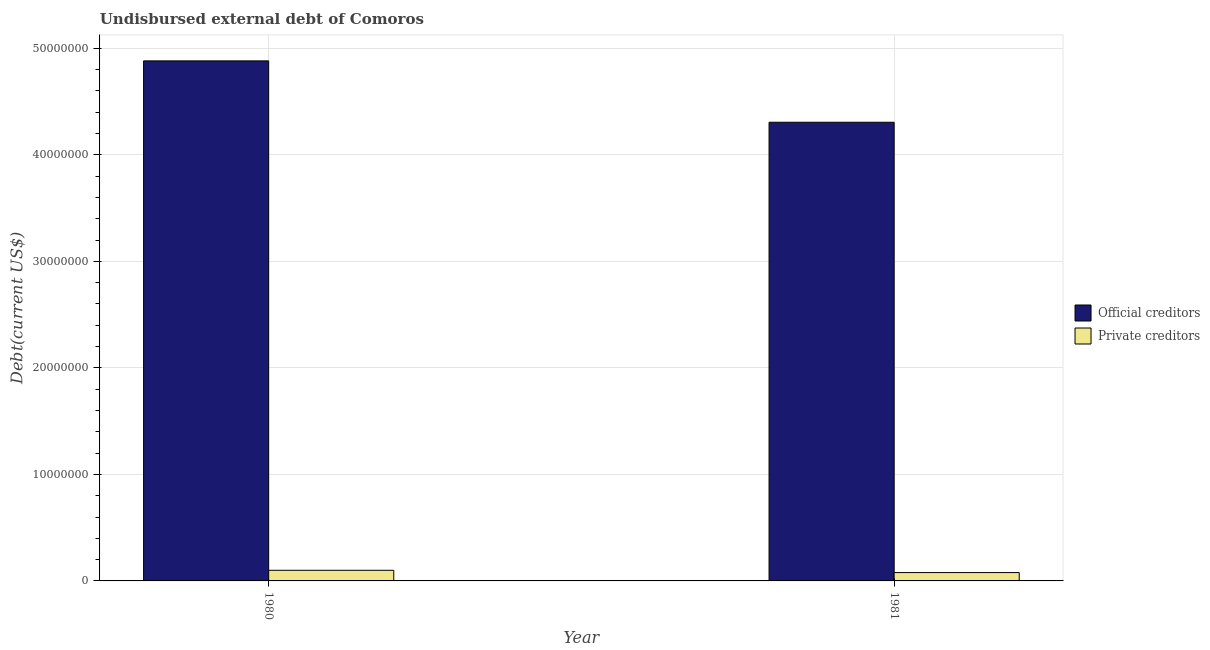What is the label of the 1st group of bars from the left?
Your response must be concise. 1980. In how many cases, is the number of bars for a given year not equal to the number of legend labels?
Keep it short and to the point. 0. What is the undisbursed external debt of private creditors in 1981?
Ensure brevity in your answer.  7.84e+05. Across all years, what is the maximum undisbursed external debt of private creditors?
Ensure brevity in your answer.  9.98e+05. Across all years, what is the minimum undisbursed external debt of official creditors?
Ensure brevity in your answer.  4.31e+07. In which year was the undisbursed external debt of official creditors maximum?
Your answer should be compact. 1980. What is the total undisbursed external debt of official creditors in the graph?
Make the answer very short. 9.19e+07. What is the difference between the undisbursed external debt of private creditors in 1980 and that in 1981?
Your response must be concise. 2.14e+05. What is the difference between the undisbursed external debt of official creditors in 1980 and the undisbursed external debt of private creditors in 1981?
Your response must be concise. 5.76e+06. What is the average undisbursed external debt of private creditors per year?
Provide a short and direct response. 8.91e+05. What is the ratio of the undisbursed external debt of official creditors in 1980 to that in 1981?
Ensure brevity in your answer.  1.13. In how many years, is the undisbursed external debt of private creditors greater than the average undisbursed external debt of private creditors taken over all years?
Your response must be concise. 1. What does the 1st bar from the left in 1980 represents?
Offer a very short reply. Official creditors. What does the 2nd bar from the right in 1980 represents?
Your answer should be very brief. Official creditors. Are the values on the major ticks of Y-axis written in scientific E-notation?
Provide a short and direct response. No. How are the legend labels stacked?
Your answer should be very brief. Vertical. What is the title of the graph?
Your answer should be compact. Undisbursed external debt of Comoros. Does "Rural" appear as one of the legend labels in the graph?
Provide a short and direct response. No. What is the label or title of the X-axis?
Make the answer very short. Year. What is the label or title of the Y-axis?
Ensure brevity in your answer.  Debt(current US$). What is the Debt(current US$) of Official creditors in 1980?
Keep it short and to the point. 4.88e+07. What is the Debt(current US$) of Private creditors in 1980?
Your answer should be very brief. 9.98e+05. What is the Debt(current US$) of Official creditors in 1981?
Your answer should be compact. 4.31e+07. What is the Debt(current US$) in Private creditors in 1981?
Keep it short and to the point. 7.84e+05. Across all years, what is the maximum Debt(current US$) of Official creditors?
Keep it short and to the point. 4.88e+07. Across all years, what is the maximum Debt(current US$) in Private creditors?
Your response must be concise. 9.98e+05. Across all years, what is the minimum Debt(current US$) of Official creditors?
Keep it short and to the point. 4.31e+07. Across all years, what is the minimum Debt(current US$) of Private creditors?
Keep it short and to the point. 7.84e+05. What is the total Debt(current US$) in Official creditors in the graph?
Provide a succinct answer. 9.19e+07. What is the total Debt(current US$) in Private creditors in the graph?
Provide a short and direct response. 1.78e+06. What is the difference between the Debt(current US$) in Official creditors in 1980 and that in 1981?
Ensure brevity in your answer.  5.76e+06. What is the difference between the Debt(current US$) of Private creditors in 1980 and that in 1981?
Give a very brief answer. 2.14e+05. What is the difference between the Debt(current US$) of Official creditors in 1980 and the Debt(current US$) of Private creditors in 1981?
Provide a short and direct response. 4.80e+07. What is the average Debt(current US$) of Official creditors per year?
Make the answer very short. 4.59e+07. What is the average Debt(current US$) in Private creditors per year?
Make the answer very short. 8.91e+05. In the year 1980, what is the difference between the Debt(current US$) in Official creditors and Debt(current US$) in Private creditors?
Keep it short and to the point. 4.78e+07. In the year 1981, what is the difference between the Debt(current US$) of Official creditors and Debt(current US$) of Private creditors?
Provide a succinct answer. 4.23e+07. What is the ratio of the Debt(current US$) in Official creditors in 1980 to that in 1981?
Your response must be concise. 1.13. What is the ratio of the Debt(current US$) in Private creditors in 1980 to that in 1981?
Offer a very short reply. 1.27. What is the difference between the highest and the second highest Debt(current US$) in Official creditors?
Ensure brevity in your answer.  5.76e+06. What is the difference between the highest and the second highest Debt(current US$) of Private creditors?
Provide a succinct answer. 2.14e+05. What is the difference between the highest and the lowest Debt(current US$) in Official creditors?
Your answer should be very brief. 5.76e+06. What is the difference between the highest and the lowest Debt(current US$) in Private creditors?
Provide a succinct answer. 2.14e+05. 